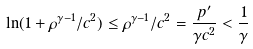<formula> <loc_0><loc_0><loc_500><loc_500>\ln ( 1 + \rho ^ { \gamma - 1 } / c ^ { 2 } ) \leq \rho ^ { \gamma - 1 } / c ^ { 2 } = \frac { { p } ^ { \prime } } { \gamma c ^ { 2 } } < \frac { 1 } { \gamma }</formula> 